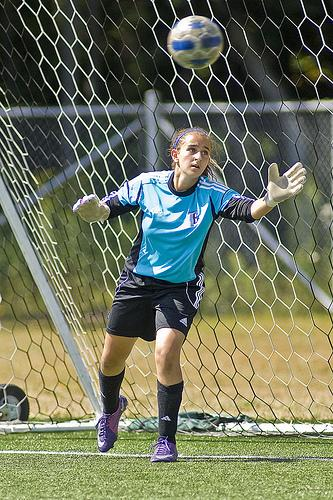What does the soccer ball look like and where is it in relation to the girl? The soccer ball is white and blue, and it is located in front of the girl who's trying to block it. How would you interpret the overall emotion or sentiment present in this image? The sentiment appears to be focused, intense, and competitive as the girl tries to block the soccer ball. What type of footwear does the girl have on and what are their colors? The girl is wearing soccer cleats that are purple and pink. Describe the object behind the girl and evaluate its purpose. There is a soccer net behind the girl which serves the purpose of catching the soccer ball during gameplay. What type of equipment is near the net and what color is it? A round black wheel or tire is located by the net. List the known characteristics of the grass on the field. The grass is green artificial turf and has a white line marking it. What type of activity is happening in the image and where do you think this takes place? There is a soccer game happening, and it most likely takes place at a soccer field. What color is the headband and where is it located on the person? The headband is blue, and it is located on the girl's head. Can you describe the girl's outfit and what she's attempting to do? The girl is wearing a blue and black soccer uniform, black socks with shinguards, purple cleats, and white goalie gloves; she's reaching out to block a soccer ball. Mention where the white adidas logo is present and describe its background. The white adidas logo can be found on the girl's black socks and shorts. 